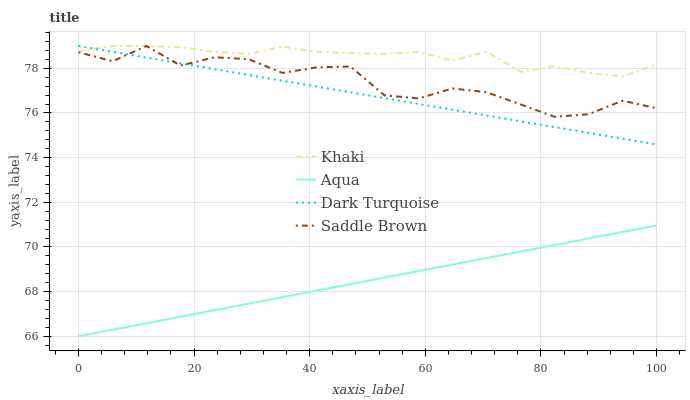Does Khaki have the minimum area under the curve?
Answer yes or no. No. Does Aqua have the maximum area under the curve?
Answer yes or no. No. Is Khaki the smoothest?
Answer yes or no. No. Is Khaki the roughest?
Answer yes or no. No. Does Khaki have the lowest value?
Answer yes or no. No. Does Aqua have the highest value?
Answer yes or no. No. Is Aqua less than Dark Turquoise?
Answer yes or no. Yes. Is Saddle Brown greater than Aqua?
Answer yes or no. Yes. Does Aqua intersect Dark Turquoise?
Answer yes or no. No. 